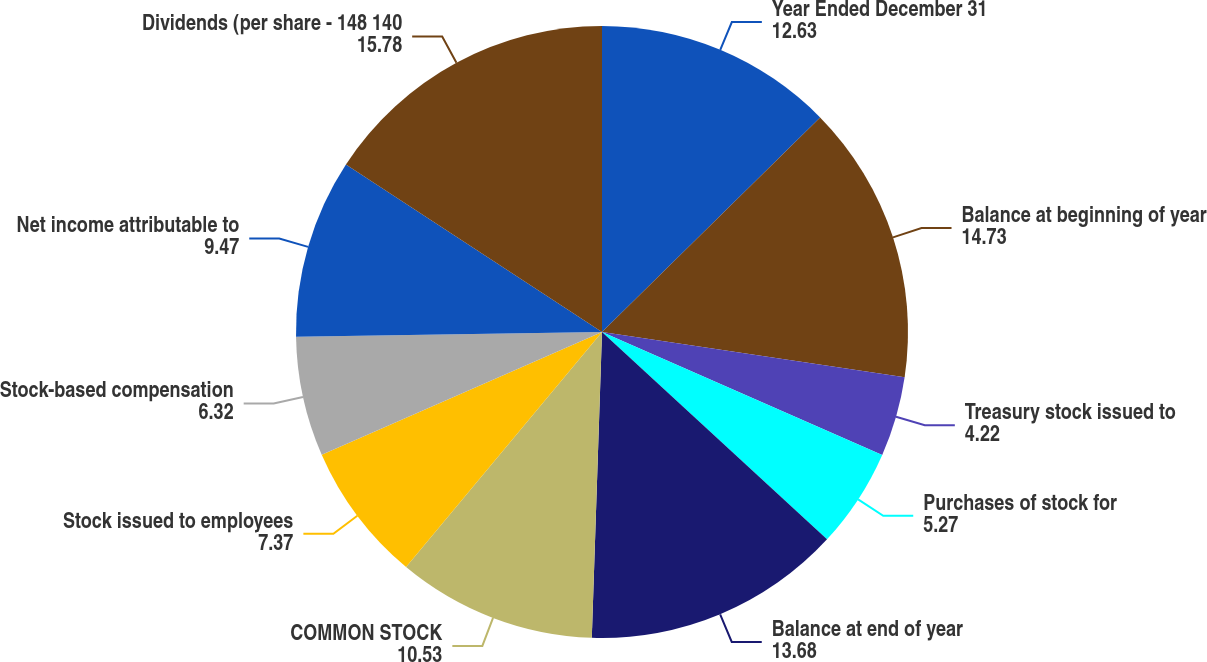Convert chart. <chart><loc_0><loc_0><loc_500><loc_500><pie_chart><fcel>Year Ended December 31<fcel>Balance at beginning of year<fcel>Treasury stock issued to<fcel>Purchases of stock for<fcel>Balance at end of year<fcel>COMMON STOCK<fcel>Stock issued to employees<fcel>Stock-based compensation<fcel>Net income attributable to<fcel>Dividends (per share - 148 140<nl><fcel>12.63%<fcel>14.73%<fcel>4.22%<fcel>5.27%<fcel>13.68%<fcel>10.53%<fcel>7.37%<fcel>6.32%<fcel>9.47%<fcel>15.78%<nl></chart> 